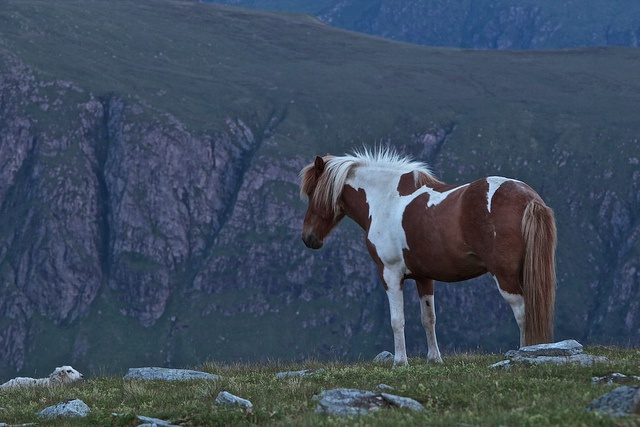Describe the objects in this image and their specific colors. I can see a horse in blue, black, gray, and darkgray tones in this image. 